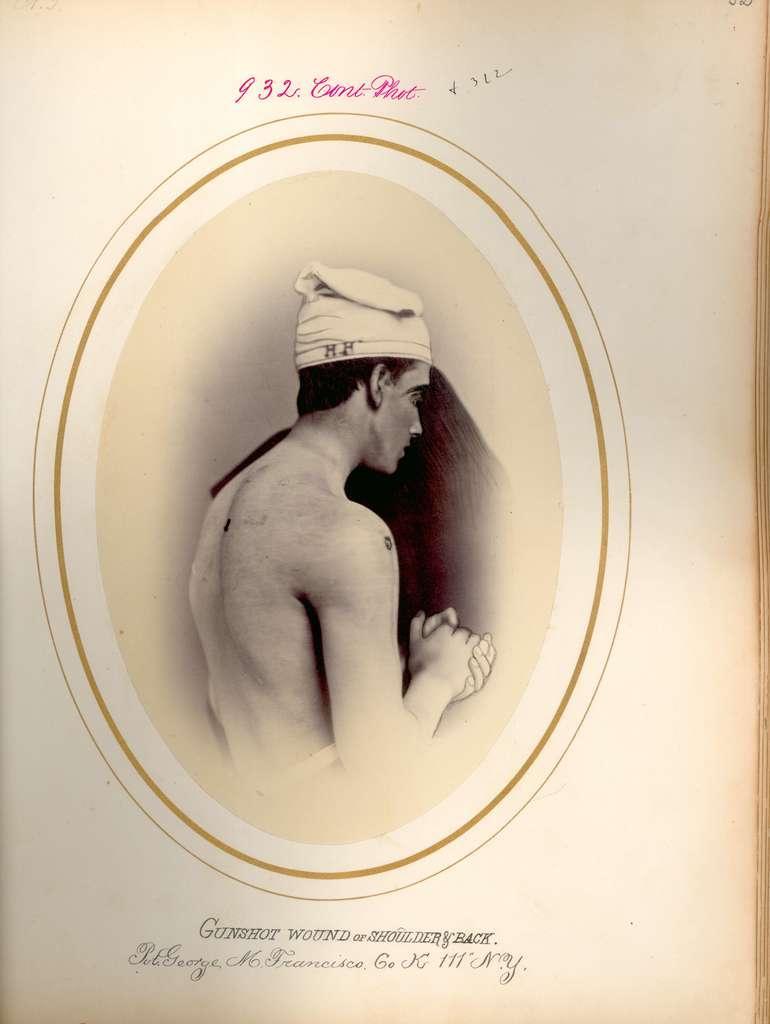In one or two sentences, can you explain what this image depicts? This picture is consists of a photograph in the image. 